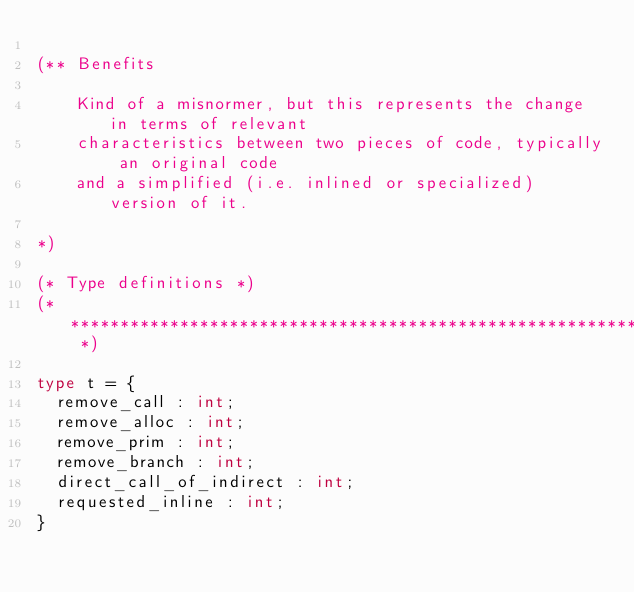<code> <loc_0><loc_0><loc_500><loc_500><_OCaml_>
(** Benefits

    Kind of a misnormer, but this represents the change in terms of relevant
    characteristics between two pieces of code, typically an original code
    and a simplified (i.e. inlined or specialized) version of it.

*)

(* Type definitions *)
(* ************************************************************************* *)

type t = {
  remove_call : int;
  remove_alloc : int;
  remove_prim : int;
  remove_branch : int;
  direct_call_of_indirect : int;
  requested_inline : int;
}

</code> 